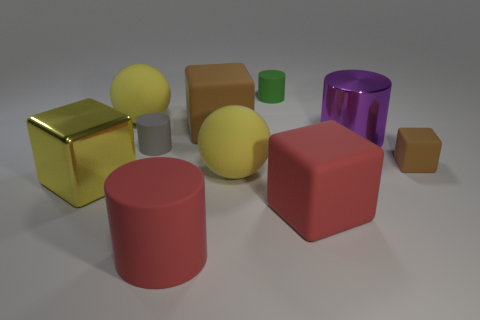Subtract all small brown blocks. How many blocks are left? 3 Subtract all purple cylinders. How many brown blocks are left? 2 Subtract all green cylinders. How many cylinders are left? 3 Subtract 2 blocks. How many blocks are left? 2 Subtract all cubes. How many objects are left? 6 Subtract all large gray things. Subtract all shiny blocks. How many objects are left? 9 Add 6 red rubber things. How many red rubber things are left? 8 Add 9 tiny matte blocks. How many tiny matte blocks exist? 10 Subtract 0 gray cubes. How many objects are left? 10 Subtract all purple cylinders. Subtract all brown balls. How many cylinders are left? 3 